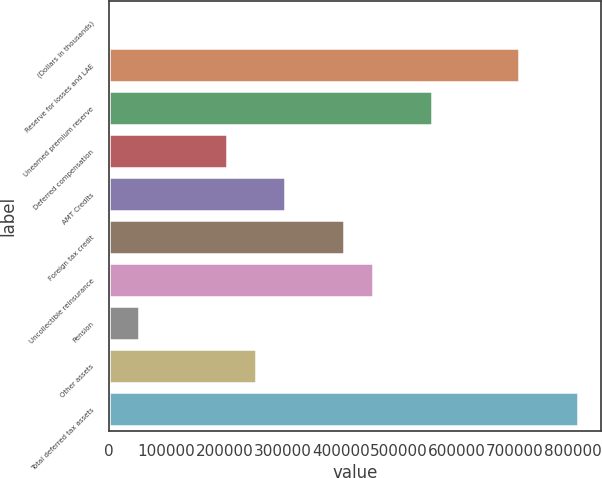Convert chart to OTSL. <chart><loc_0><loc_0><loc_500><loc_500><bar_chart><fcel>(Dollars in thousands)<fcel>Reserve for losses and LAE<fcel>Unearned premium reserve<fcel>Deferred compensation<fcel>AMT Credits<fcel>Foreign tax credit<fcel>Uncollectible reinsurance<fcel>Pension<fcel>Other assets<fcel>Total deferred tax assets<nl><fcel>2007<fcel>707880<fcel>556622<fcel>203685<fcel>304524<fcel>405363<fcel>455782<fcel>52426.5<fcel>254104<fcel>808719<nl></chart> 